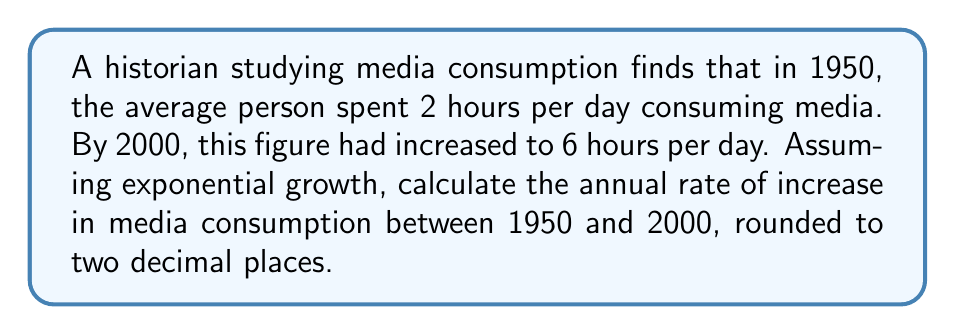Help me with this question. To solve this problem, we'll use the exponential growth formula:

$$ A = P(1 + r)^t $$

Where:
$A$ = Final amount (6 hours)
$P$ = Initial amount (2 hours)
$r$ = Annual rate of growth (what we're solving for)
$t$ = Time period (50 years)

1. Plug in the known values:
   $$ 6 = 2(1 + r)^{50} $$

2. Divide both sides by 2:
   $$ 3 = (1 + r)^{50} $$

3. Take the 50th root of both sides:
   $$ \sqrt[50]{3} = 1 + r $$

4. Subtract 1 from both sides:
   $$ \sqrt[50]{3} - 1 = r $$

5. Calculate the value:
   $$ r \approx 0.0222 $$

6. Convert to a percentage and round to two decimal places:
   $$ r \approx 2.22\% $$
Answer: 2.22% 